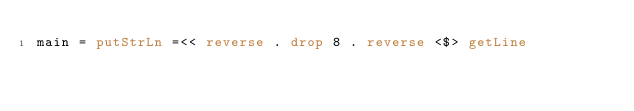Convert code to text. <code><loc_0><loc_0><loc_500><loc_500><_Haskell_>main = putStrLn =<< reverse . drop 8 . reverse <$> getLine</code> 